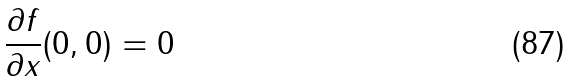<formula> <loc_0><loc_0><loc_500><loc_500>\frac { \partial f } { \partial x } ( 0 , 0 ) = 0</formula> 